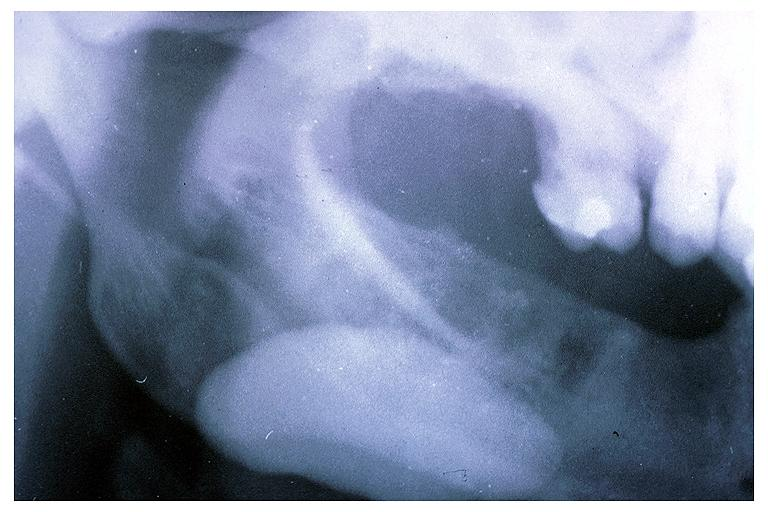s immunoperoxidate present?
Answer the question using a single word or phrase. No 